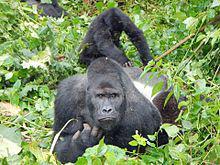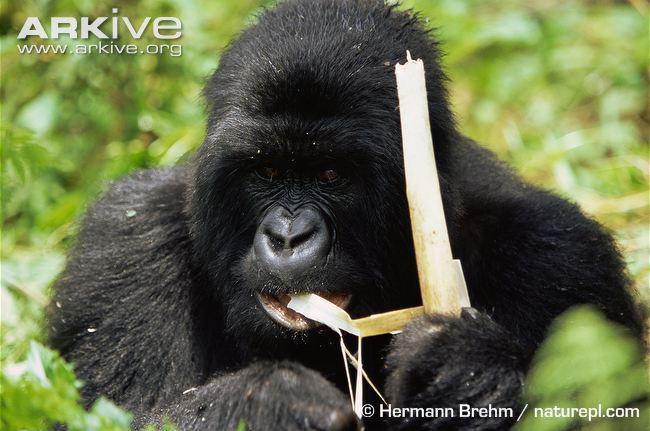The first image is the image on the left, the second image is the image on the right. Analyze the images presented: Is the assertion "A gorilla is eating something in one of the images." valid? Answer yes or no. Yes. The first image is the image on the left, the second image is the image on the right. For the images shown, is this caption "An image shows one gorilla munching on something." true? Answer yes or no. Yes. 